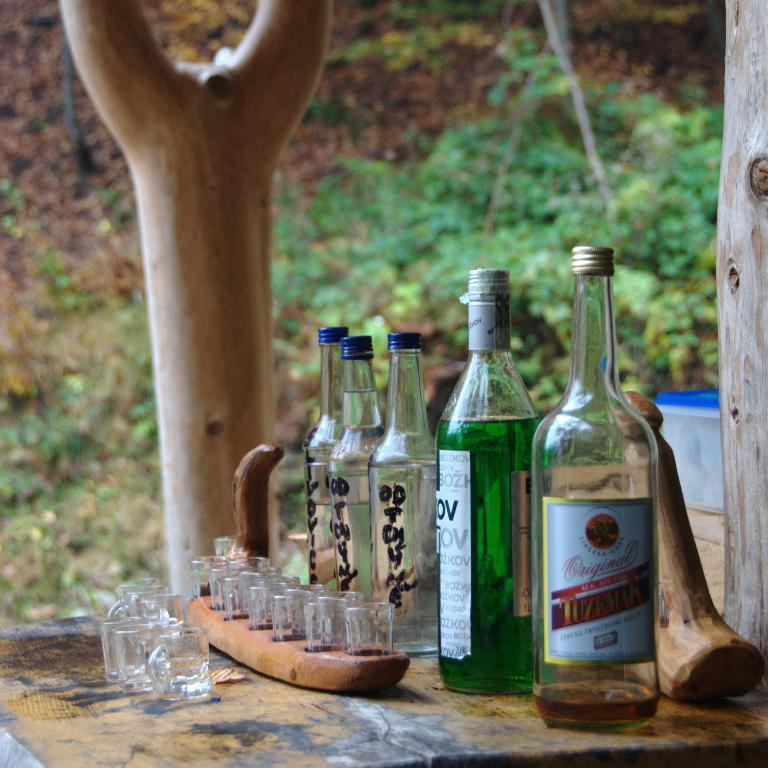How many bottles are on the wooden table in the image? There are five bottles on a wooden table in the image. What else is present on the wooden table? There are no other items mentioned on the wooden table besides the bottles. What is the wooden tray holding? The wooden tray is holding glasses. What can be seen in the background of the image? There are trees in the background of the image. Is there a playground visible in the image? No, there is no playground present in the image. What type of needle can be seen in the image? There are no needles present in the image. 